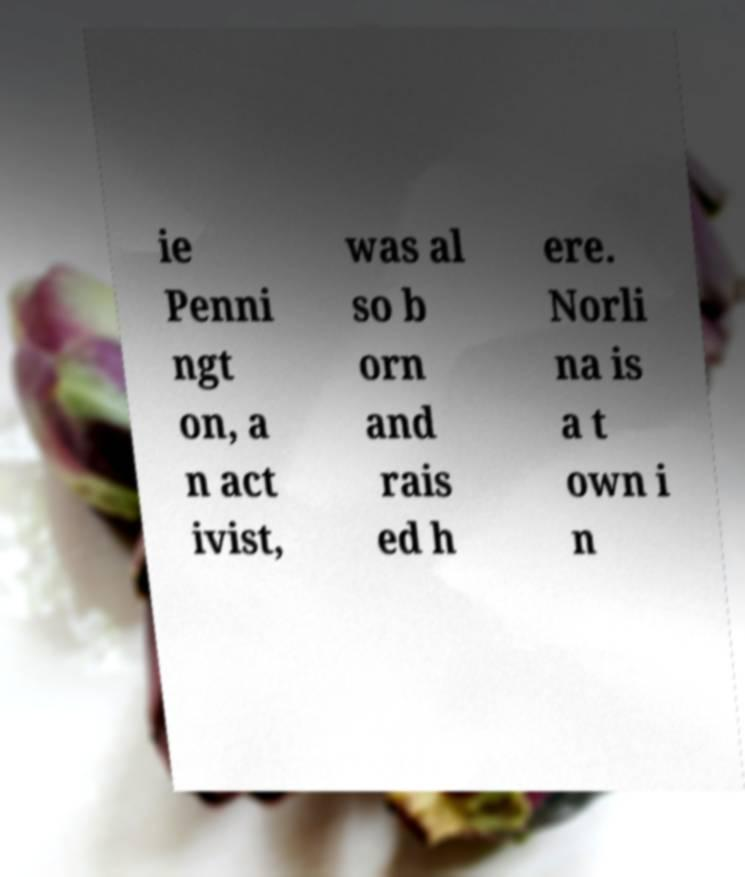Can you accurately transcribe the text from the provided image for me? ie Penni ngt on, a n act ivist, was al so b orn and rais ed h ere. Norli na is a t own i n 